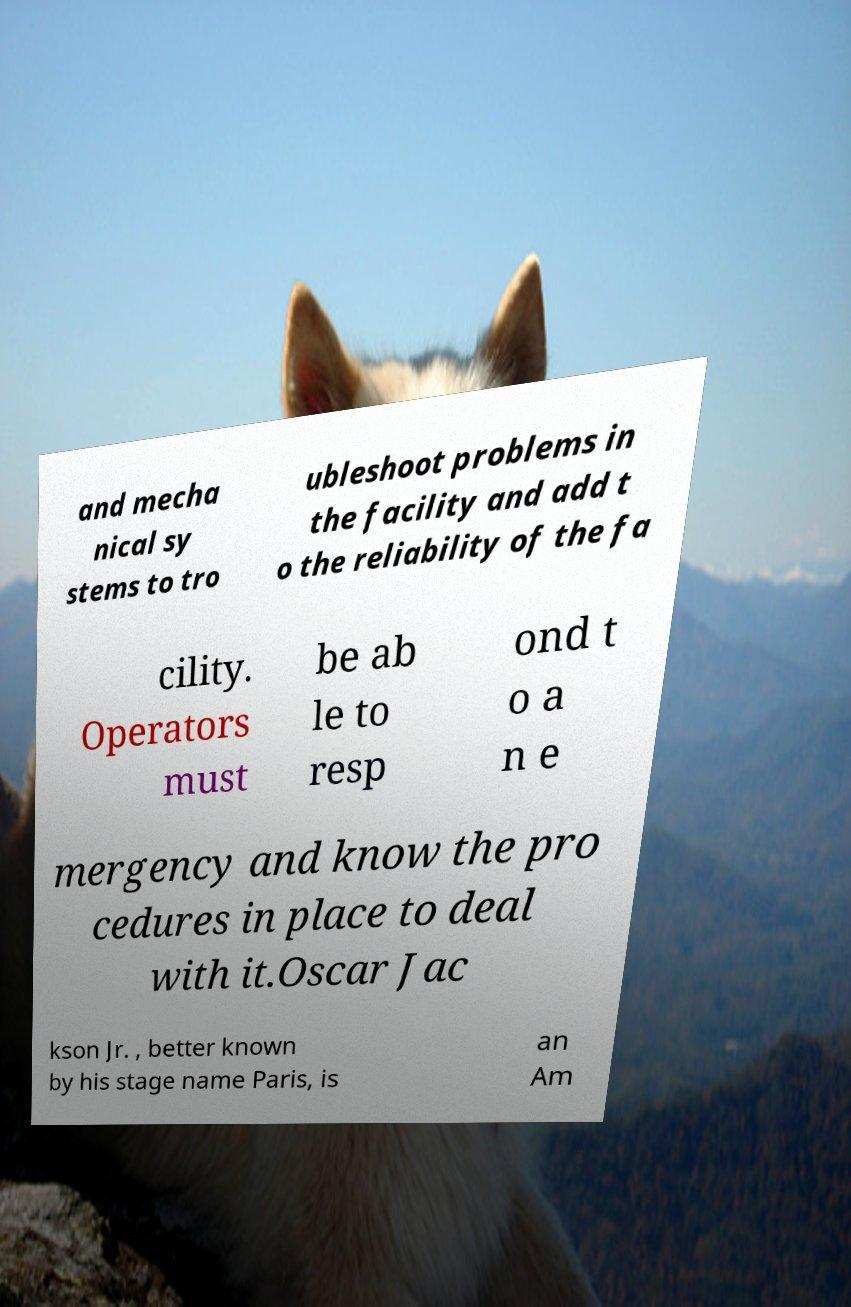For documentation purposes, I need the text within this image transcribed. Could you provide that? and mecha nical sy stems to tro ubleshoot problems in the facility and add t o the reliability of the fa cility. Operators must be ab le to resp ond t o a n e mergency and know the pro cedures in place to deal with it.Oscar Jac kson Jr. , better known by his stage name Paris, is an Am 